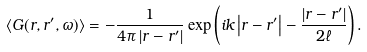<formula> <loc_0><loc_0><loc_500><loc_500>\langle G ( r , r ^ { \prime } , \omega ) \rangle = - \frac { 1 } { 4 \pi \left | r - r ^ { \prime } \right | } \exp \left ( i k \left | r - r ^ { \prime } \right | - \frac { \left | r - r ^ { \prime } \right | } { 2 \ell } \right ) .</formula> 